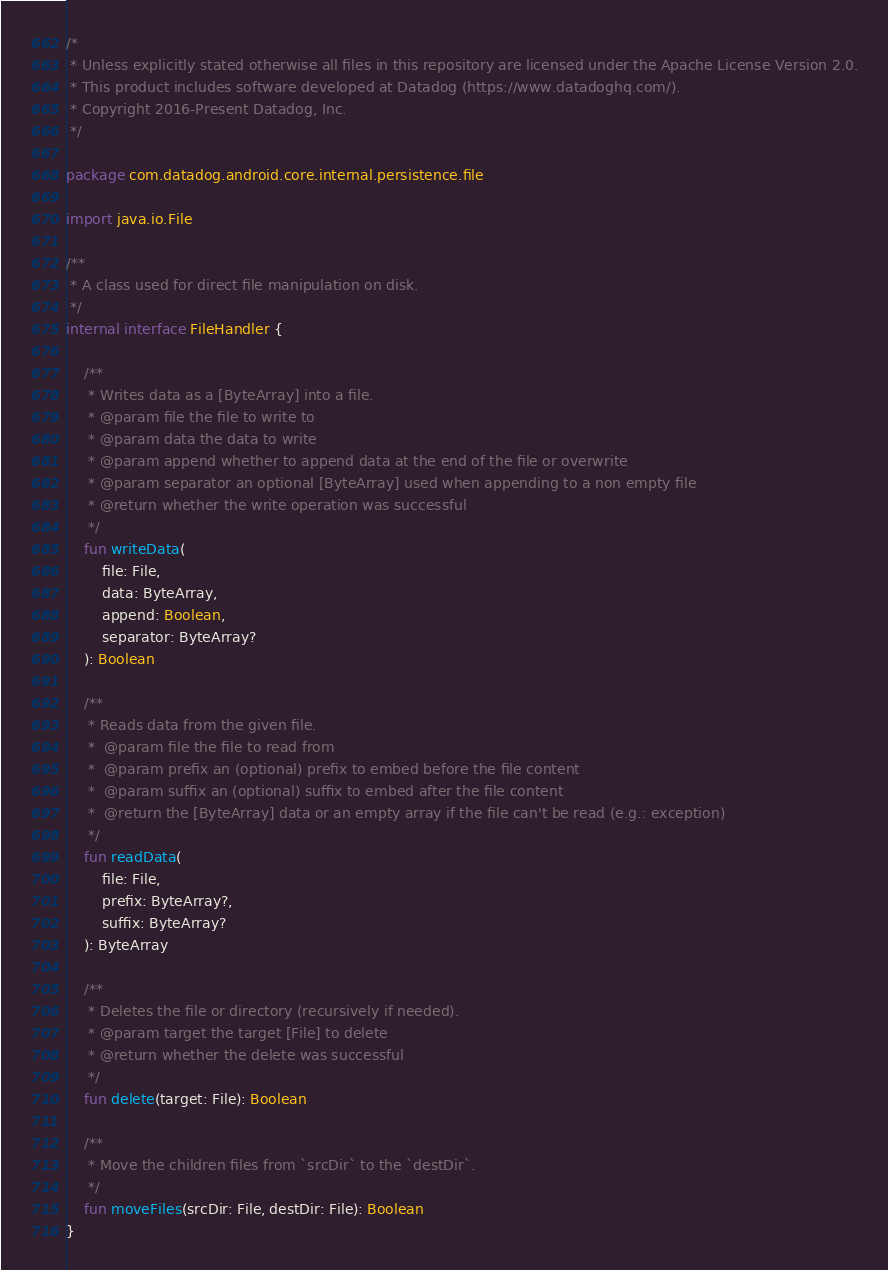<code> <loc_0><loc_0><loc_500><loc_500><_Kotlin_>/*
 * Unless explicitly stated otherwise all files in this repository are licensed under the Apache License Version 2.0.
 * This product includes software developed at Datadog (https://www.datadoghq.com/).
 * Copyright 2016-Present Datadog, Inc.
 */

package com.datadog.android.core.internal.persistence.file

import java.io.File

/**
 * A class used for direct file manipulation on disk.
 */
internal interface FileHandler {

    /**
     * Writes data as a [ByteArray] into a file.
     * @param file the file to write to
     * @param data the data to write
     * @param append whether to append data at the end of the file or overwrite
     * @param separator an optional [ByteArray] used when appending to a non empty file
     * @return whether the write operation was successful
     */
    fun writeData(
        file: File,
        data: ByteArray,
        append: Boolean,
        separator: ByteArray?
    ): Boolean

    /**
     * Reads data from the given file.
     *  @param file the file to read from
     *  @param prefix an (optional) prefix to embed before the file content
     *  @param suffix an (optional) suffix to embed after the file content
     *  @return the [ByteArray] data or an empty array if the file can't be read (e.g.: exception)
     */
    fun readData(
        file: File,
        prefix: ByteArray?,
        suffix: ByteArray?
    ): ByteArray

    /**
     * Deletes the file or directory (recursively if needed).
     * @param target the target [File] to delete
     * @return whether the delete was successful
     */
    fun delete(target: File): Boolean

    /**
     * Move the children files from `srcDir` to the `destDir`.
     */
    fun moveFiles(srcDir: File, destDir: File): Boolean
}
</code> 